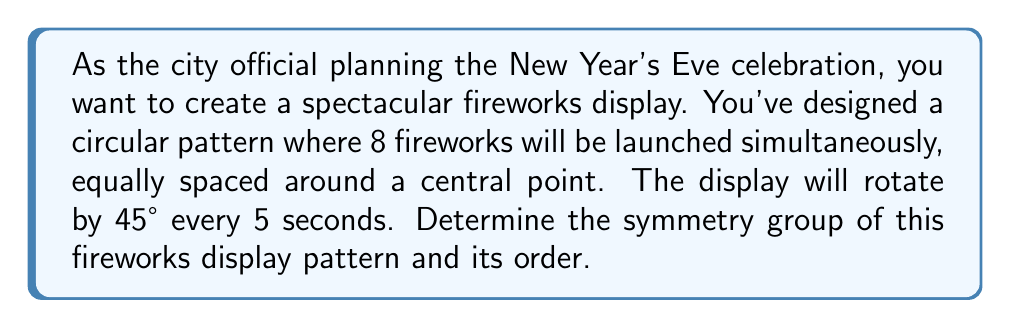Give your solution to this math problem. To determine the symmetry group of this fireworks display pattern, we need to consider both rotational and reflectional symmetries:

1. Rotational Symmetry:
   - The pattern has 8 equally spaced fireworks, so it has 8-fold rotational symmetry.
   - Rotations of 45°, 90°, 135°, 180°, 225°, 270°, 315°, and 360° (0°) all preserve the pattern.
   - This gives us 8 rotational symmetries, including the identity rotation (360° or 0°).

2. Reflectional Symmetry:
   - The pattern has 8 lines of reflection: 4 passing through opposite fireworks and 4 passing between adjacent fireworks.

3. Symmetry Group:
   - The symmetry group of this pattern is the dihedral group $D_8$.
   - $D_8$ consists of 8 rotations and 8 reflections.

4. Order of the Group:
   - The order of a group is the number of elements in the group.
   - For $D_8$, we have 8 rotations and 8 reflections.
   - Therefore, the order of $D_8$ is 8 + 8 = 16.

5. Group Structure:
   - $D_8$ can be generated by two elements: $r$ (rotation by 45°) and $s$ (reflection).
   - The group has the presentation: $D_8 = \langle r, s | r^8 = s^2 = 1, srs = r^{-1} \rangle$

6. Subgroups:
   - $D_8$ has several subgroups, including $C_8$ (cyclic group of order 8, rotations only) and $C_2$ (reflections only).

The symmetry group $D_8$ fully describes all the ways in which the fireworks display pattern remains unchanged under rotations and reflections.
Answer: The symmetry group of the fireworks display pattern is the dihedral group $D_8$, with order 16. 